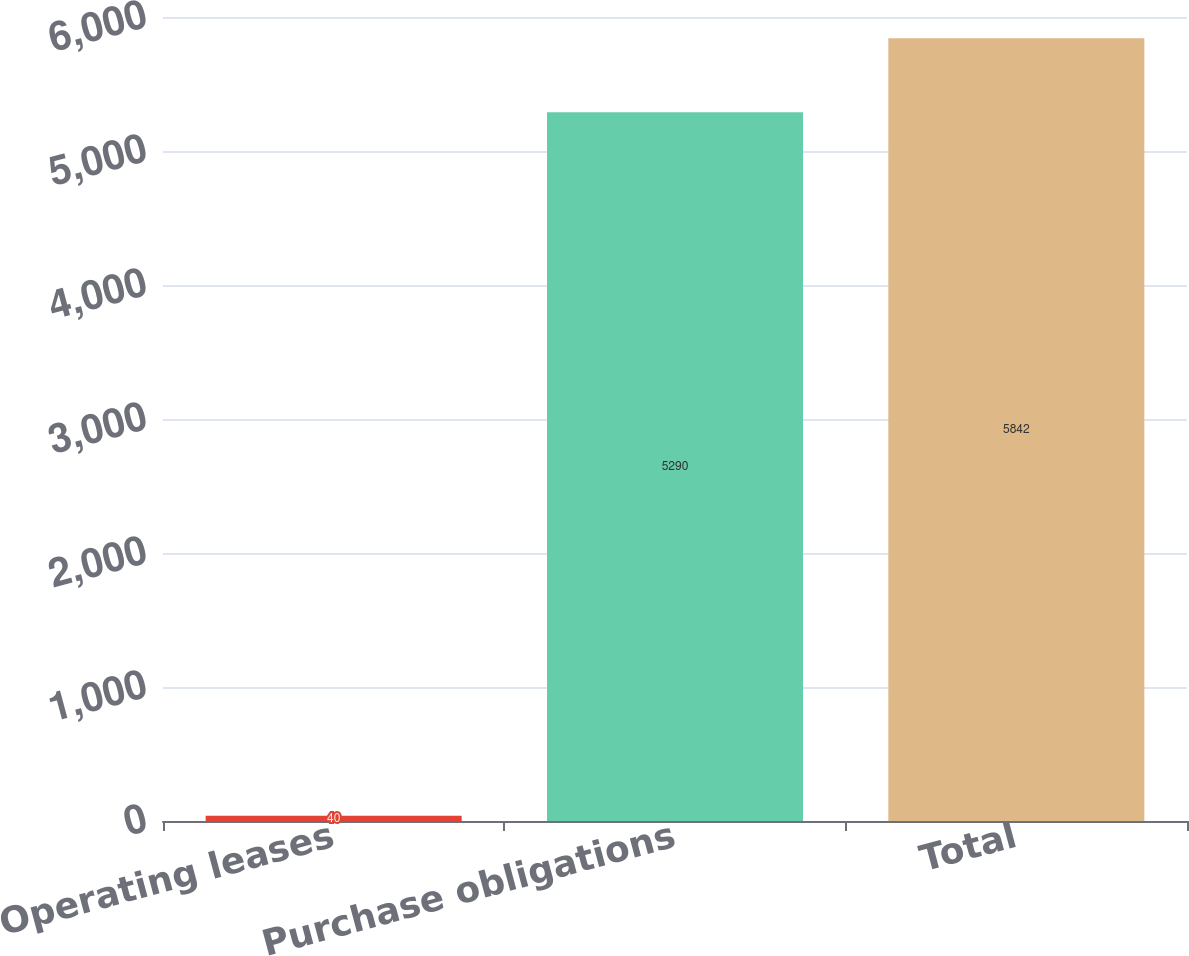Convert chart to OTSL. <chart><loc_0><loc_0><loc_500><loc_500><bar_chart><fcel>Operating leases<fcel>Purchase obligations<fcel>Total<nl><fcel>40<fcel>5290<fcel>5842<nl></chart> 